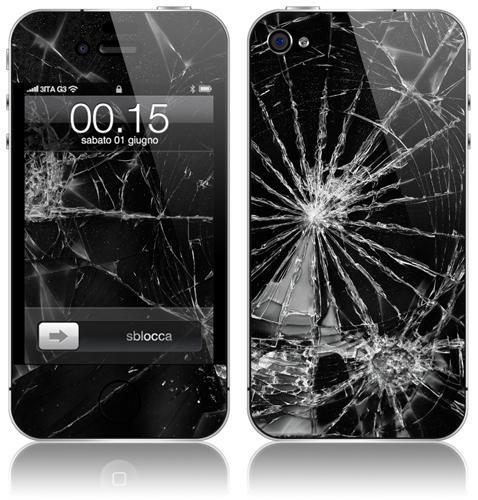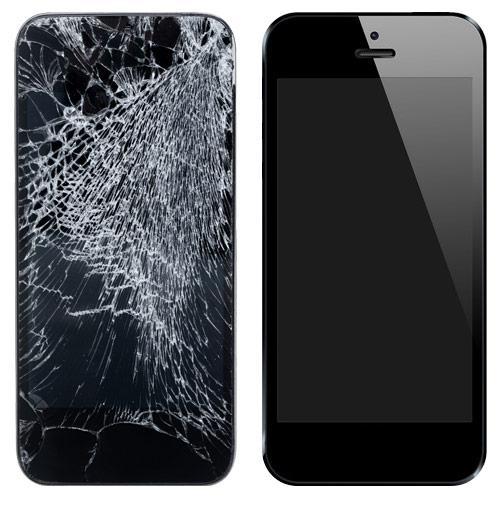The first image is the image on the left, the second image is the image on the right. Given the left and right images, does the statement "Each image contains exactly two phones, and the phones depicted are displayed upright but not overlapping." hold true? Answer yes or no. Yes. 